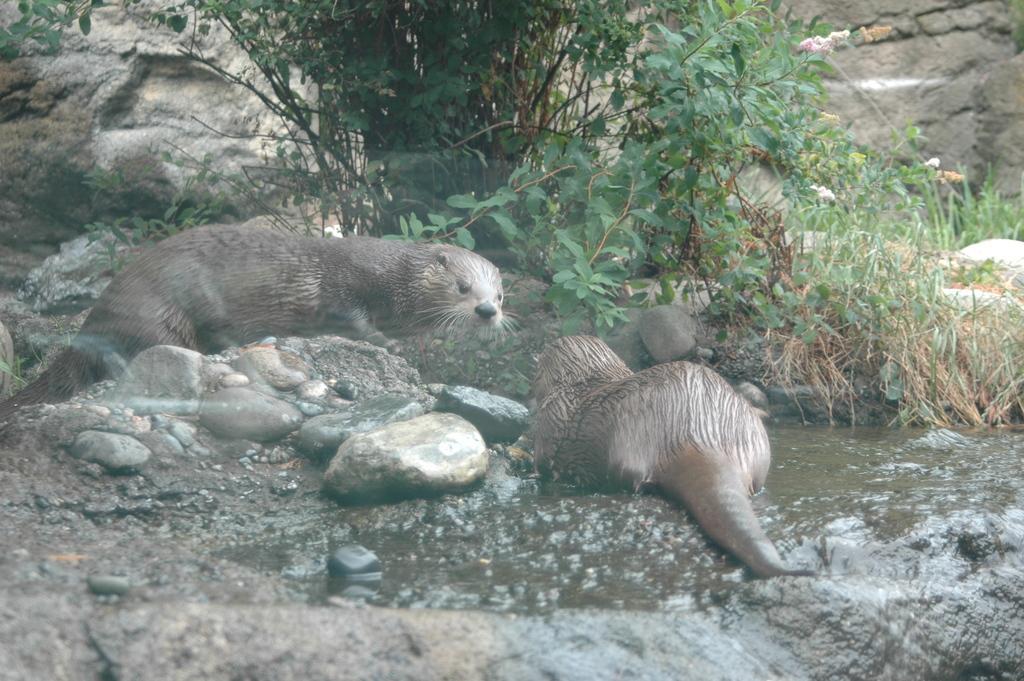Describe this image in one or two sentences. This image is clicked outside. There are plants at the top and middle. There are animals in the middle. 